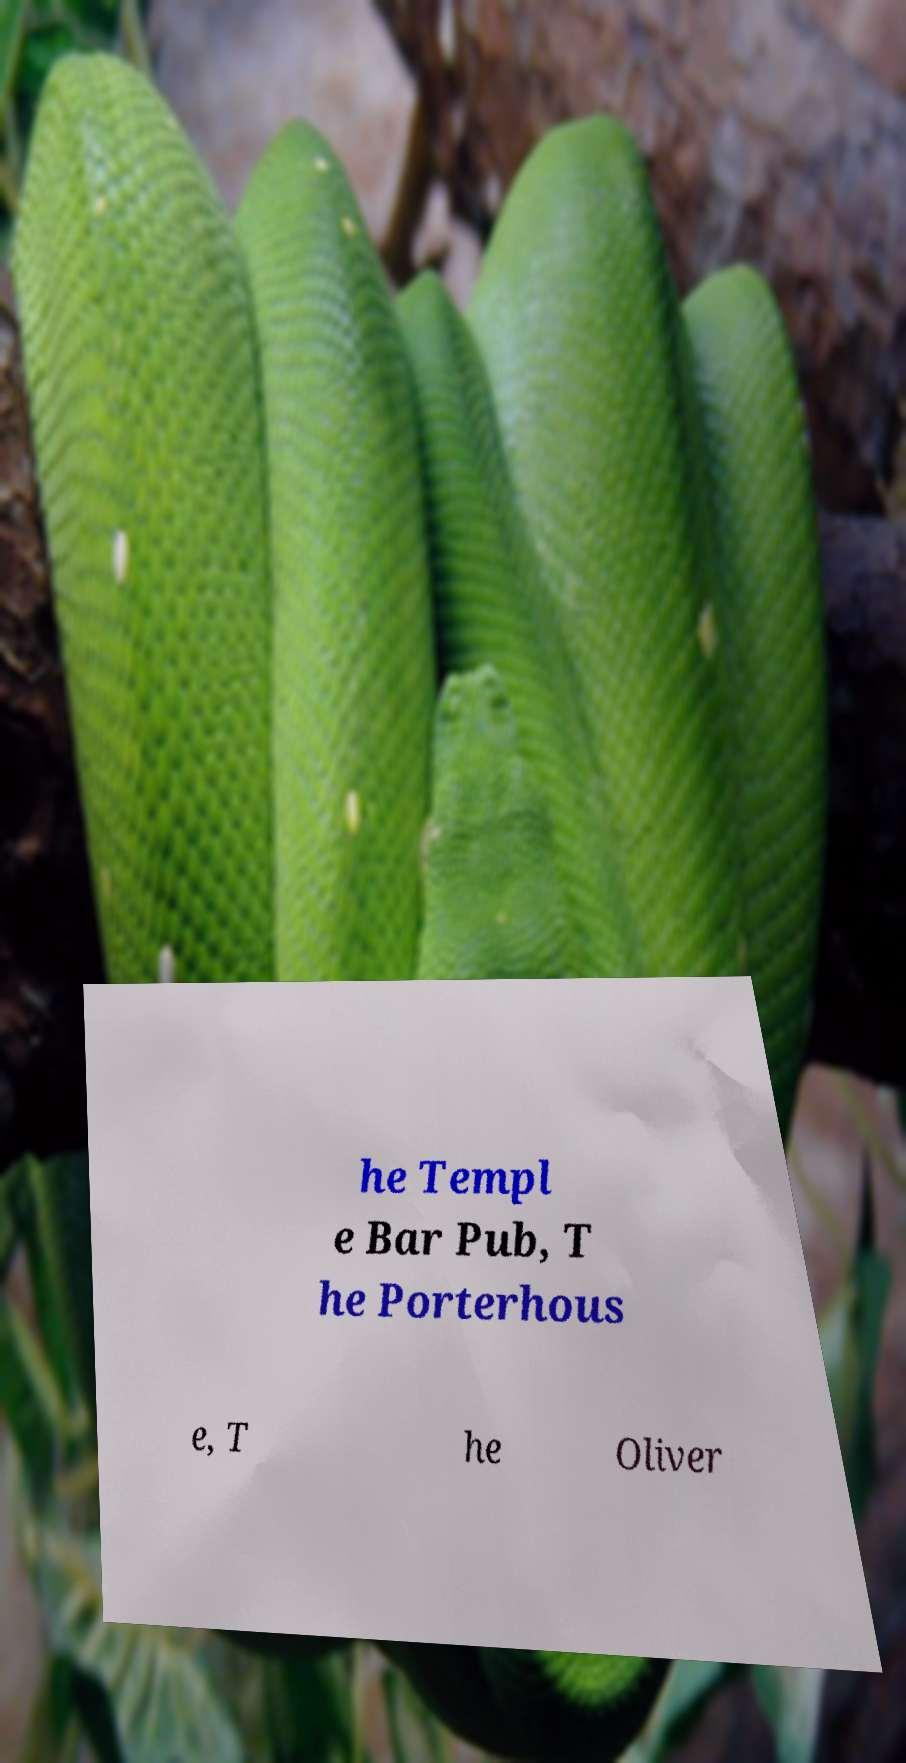Can you read and provide the text displayed in the image?This photo seems to have some interesting text. Can you extract and type it out for me? he Templ e Bar Pub, T he Porterhous e, T he Oliver 